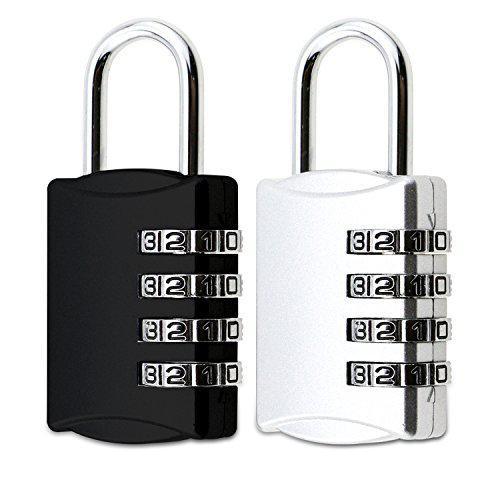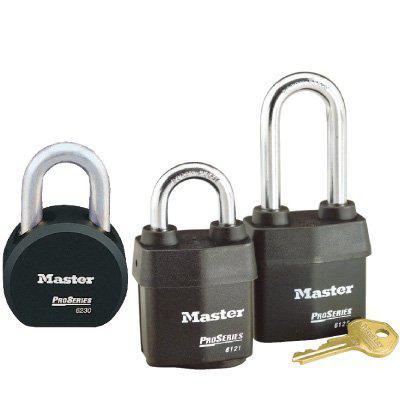The first image is the image on the left, the second image is the image on the right. Assess this claim about the two images: "There are more locks in the image on the right than in the image on the left.". Correct or not? Answer yes or no. Yes. The first image is the image on the left, the second image is the image on the right. For the images shown, is this caption "An image shows a stack of two black-topped keys next to two overlapping upright black padlocks." true? Answer yes or no. No. 